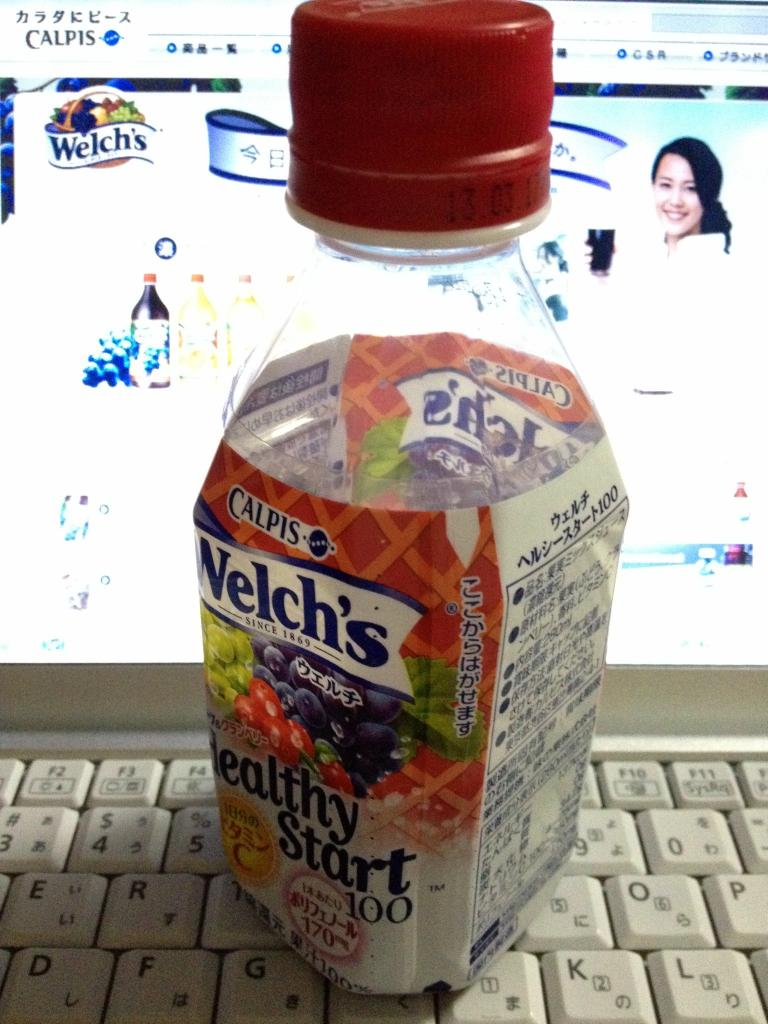Can you tell me more about the collaboration between Welch’s and Calpis as seen on the label? The label on the bottle represents a collaborative product between Welch’s, known for its fruit juices, and Calpis, which offers dairy-based beverages in Japan. This partnership likely aims to blend the fruity flavors of Welch's with the unique fermented taste of Calpis, targeting health-conscious consumers with a new type of beverage option. 